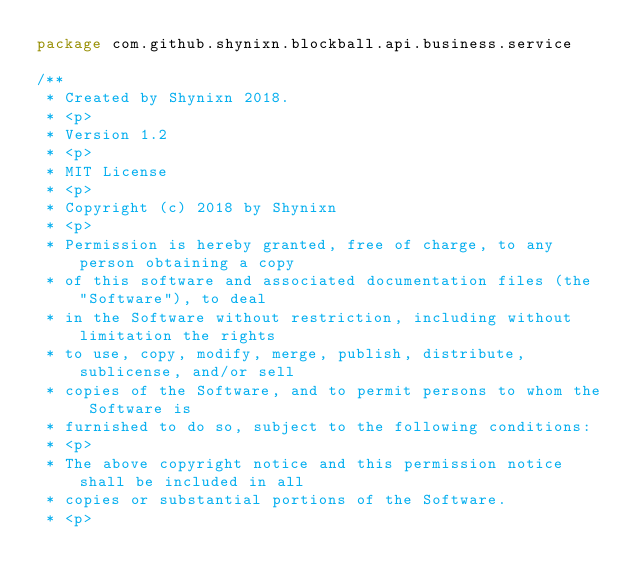Convert code to text. <code><loc_0><loc_0><loc_500><loc_500><_Kotlin_>package com.github.shynixn.blockball.api.business.service

/**
 * Created by Shynixn 2018.
 * <p>
 * Version 1.2
 * <p>
 * MIT License
 * <p>
 * Copyright (c) 2018 by Shynixn
 * <p>
 * Permission is hereby granted, free of charge, to any person obtaining a copy
 * of this software and associated documentation files (the "Software"), to deal
 * in the Software without restriction, including without limitation the rights
 * to use, copy, modify, merge, publish, distribute, sublicense, and/or sell
 * copies of the Software, and to permit persons to whom the Software is
 * furnished to do so, subject to the following conditions:
 * <p>
 * The above copyright notice and this permission notice shall be included in all
 * copies or substantial portions of the Software.
 * <p></code> 